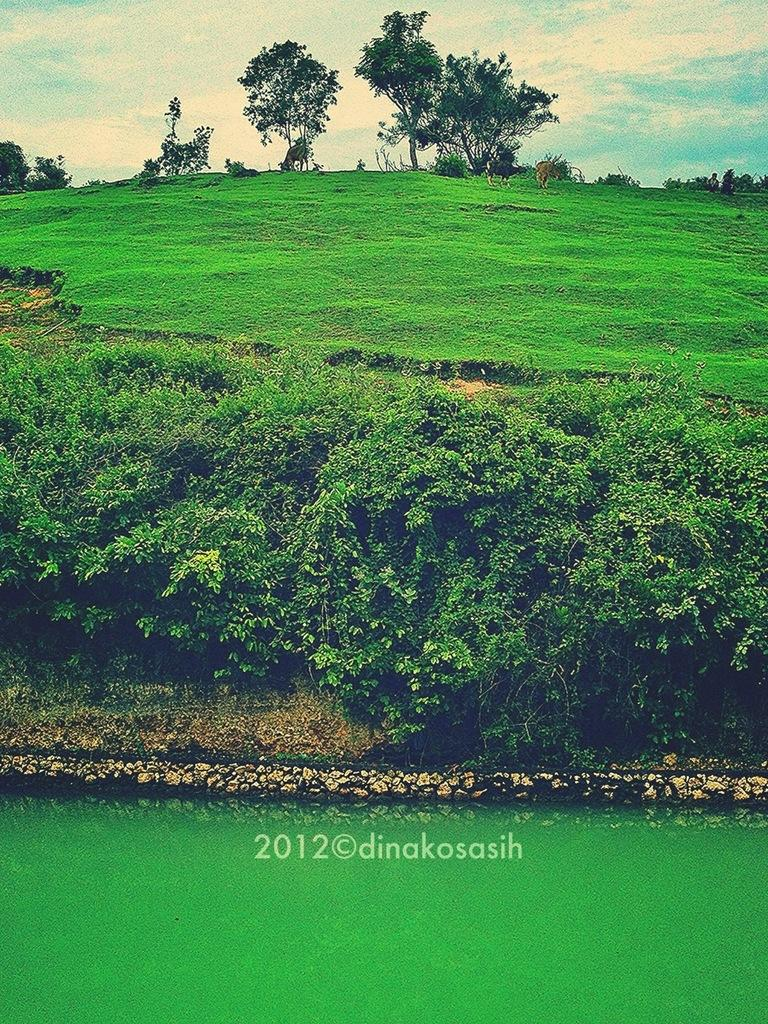What type of vegetation can be seen in the image? There are trees in the image. What is the color of the grass in the image? There is green grass in the image. What is unusual about the water in the image? The water in the image is green-colored. How would you describe the sky in the image? The sky is blue and white in color. How many nails are used to hold the destruction together in the image? There is no destruction or nails present in the image; it features trees, grass, green-colored water, and a blue and white sky. 